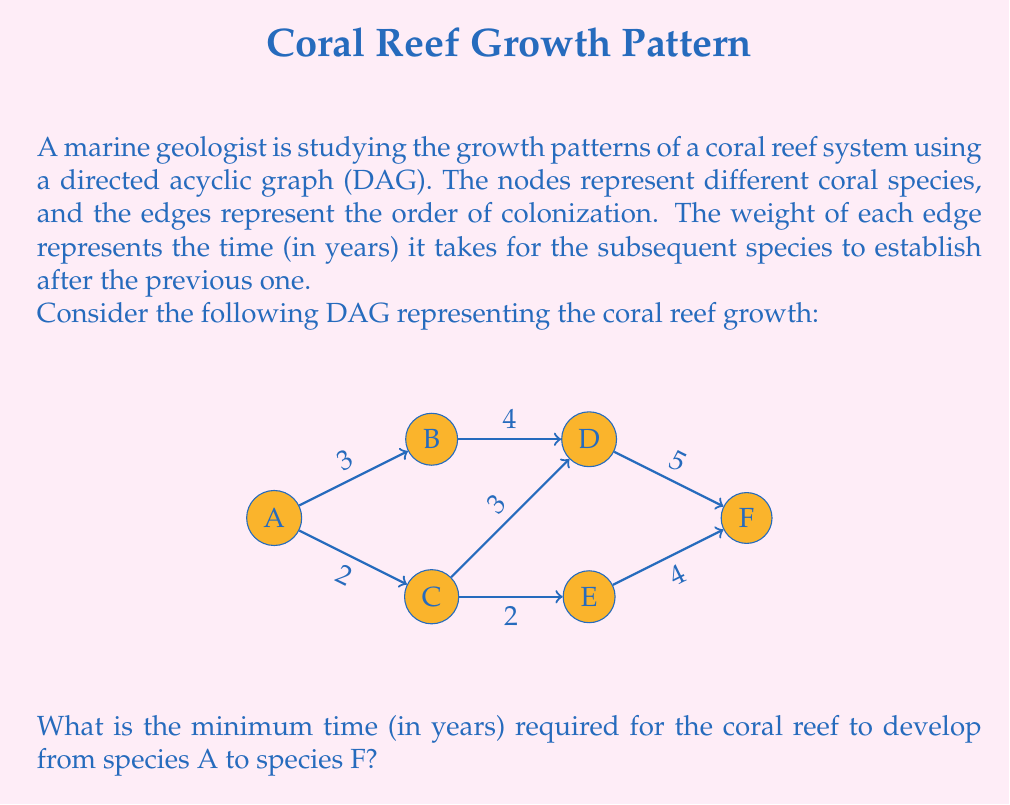Give your solution to this math problem. To find the minimum time required for the coral reef to develop from species A to species F, we need to find the longest path in the DAG, which is also known as the critical path. This can be done using dynamic programming:

1) First, let's define a function $T(v)$ that represents the minimum time to reach node $v$ from node A.

2) We can calculate $T(v)$ for each node as follows:
   $T(v) = \max_{u \in \text{predecessors}(v)} \{T(u) + w(u,v)\}$
   where $w(u,v)$ is the weight of the edge from $u$ to $v$.

3) Let's calculate $T(v)$ for each node:

   $T(A) = 0$ (starting point)
   
   $T(B) = T(A) + 3 = 3$
   
   $T(C) = T(A) + 2 = 2$
   
   $T(D) = \max\{T(B) + 4, T(C) + 3\} = \max\{7, 5\} = 7$
   
   $T(E) = T(C) + 2 = 4$
   
   $T(F) = \max\{T(D) + 5, T(E) + 4\} = \max\{12, 8\} = 12$

4) The minimum time required to reach F from A is $T(F) = 12$ years.

5) The critical path is A → B → D → F, which takes 3 + 4 + 5 = 12 years.
Answer: 12 years 